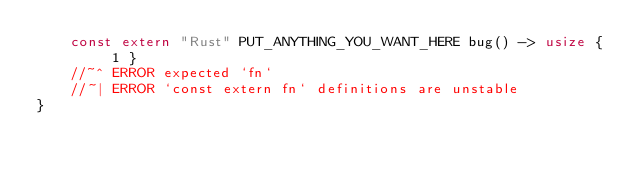Convert code to text. <code><loc_0><loc_0><loc_500><loc_500><_Rust_>    const extern "Rust" PUT_ANYTHING_YOU_WANT_HERE bug() -> usize { 1 }
    //~^ ERROR expected `fn`
    //~| ERROR `const extern fn` definitions are unstable
}
</code> 